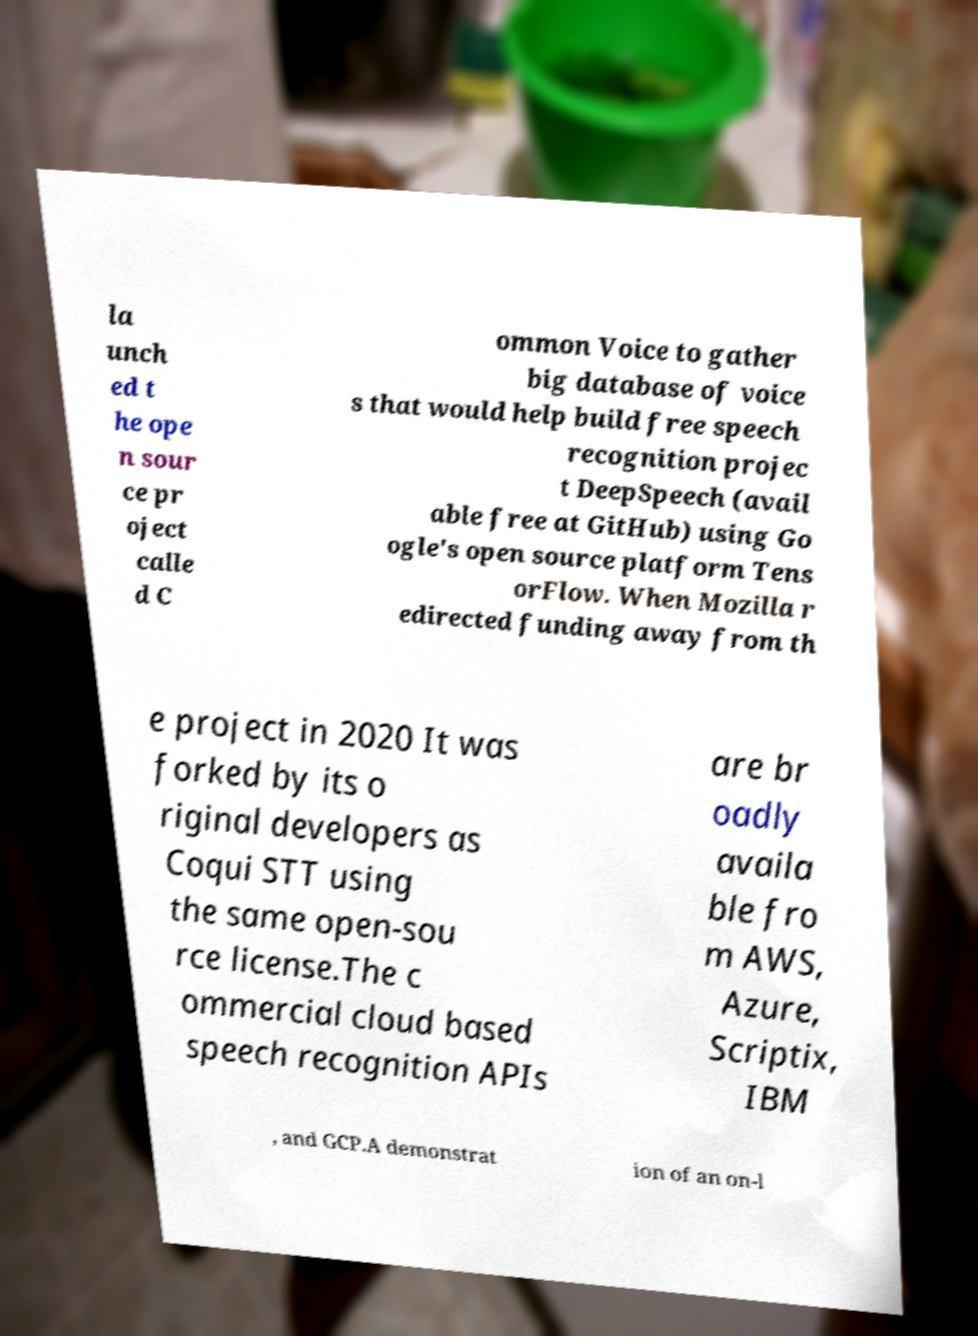For documentation purposes, I need the text within this image transcribed. Could you provide that? la unch ed t he ope n sour ce pr oject calle d C ommon Voice to gather big database of voice s that would help build free speech recognition projec t DeepSpeech (avail able free at GitHub) using Go ogle's open source platform Tens orFlow. When Mozilla r edirected funding away from th e project in 2020 It was forked by its o riginal developers as Coqui STT using the same open-sou rce license.The c ommercial cloud based speech recognition APIs are br oadly availa ble fro m AWS, Azure, Scriptix, IBM , and GCP.A demonstrat ion of an on-l 